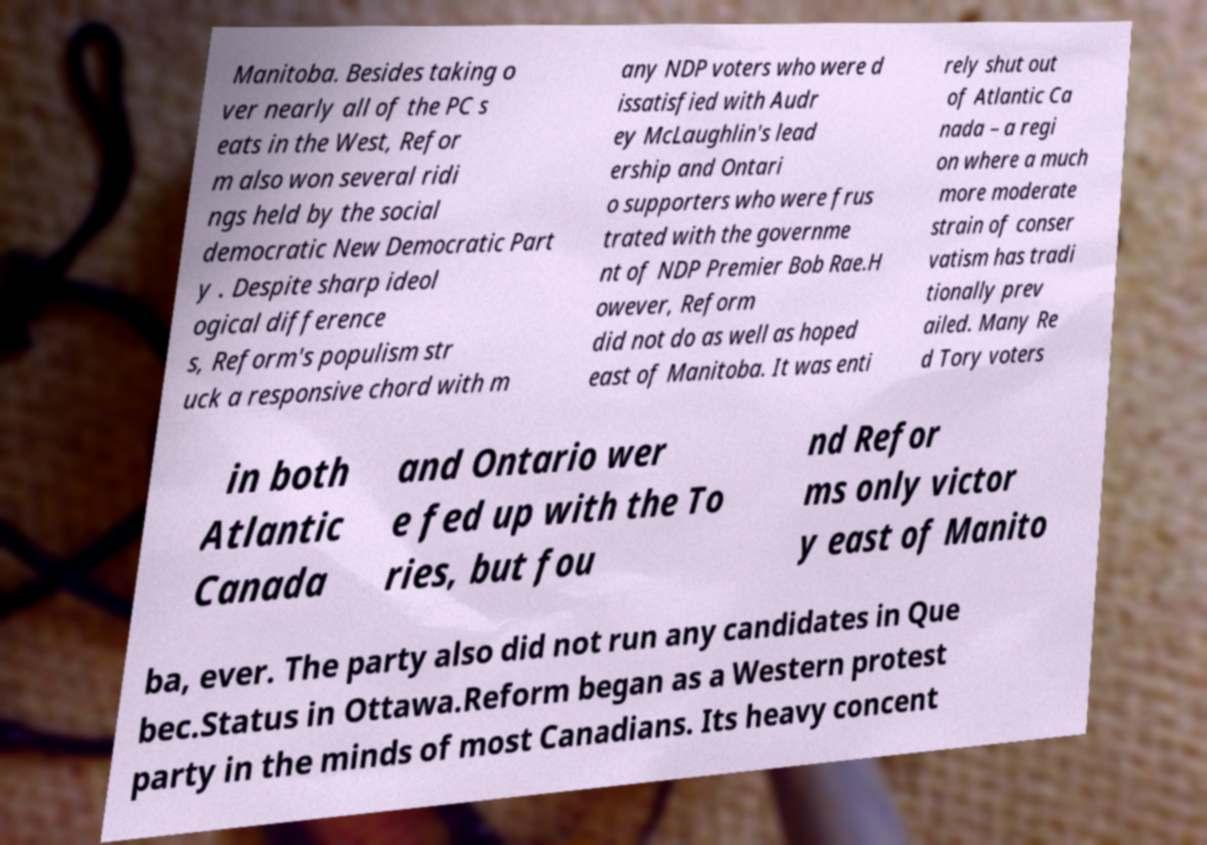Can you accurately transcribe the text from the provided image for me? Manitoba. Besides taking o ver nearly all of the PC s eats in the West, Refor m also won several ridi ngs held by the social democratic New Democratic Part y . Despite sharp ideol ogical difference s, Reform's populism str uck a responsive chord with m any NDP voters who were d issatisfied with Audr ey McLaughlin's lead ership and Ontari o supporters who were frus trated with the governme nt of NDP Premier Bob Rae.H owever, Reform did not do as well as hoped east of Manitoba. It was enti rely shut out of Atlantic Ca nada – a regi on where a much more moderate strain of conser vatism has tradi tionally prev ailed. Many Re d Tory voters in both Atlantic Canada and Ontario wer e fed up with the To ries, but fou nd Refor ms only victor y east of Manito ba, ever. The party also did not run any candidates in Que bec.Status in Ottawa.Reform began as a Western protest party in the minds of most Canadians. Its heavy concent 